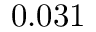Convert formula to latex. <formula><loc_0><loc_0><loc_500><loc_500>0 . 0 3 1</formula> 